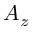<formula> <loc_0><loc_0><loc_500><loc_500>A _ { z }</formula> 